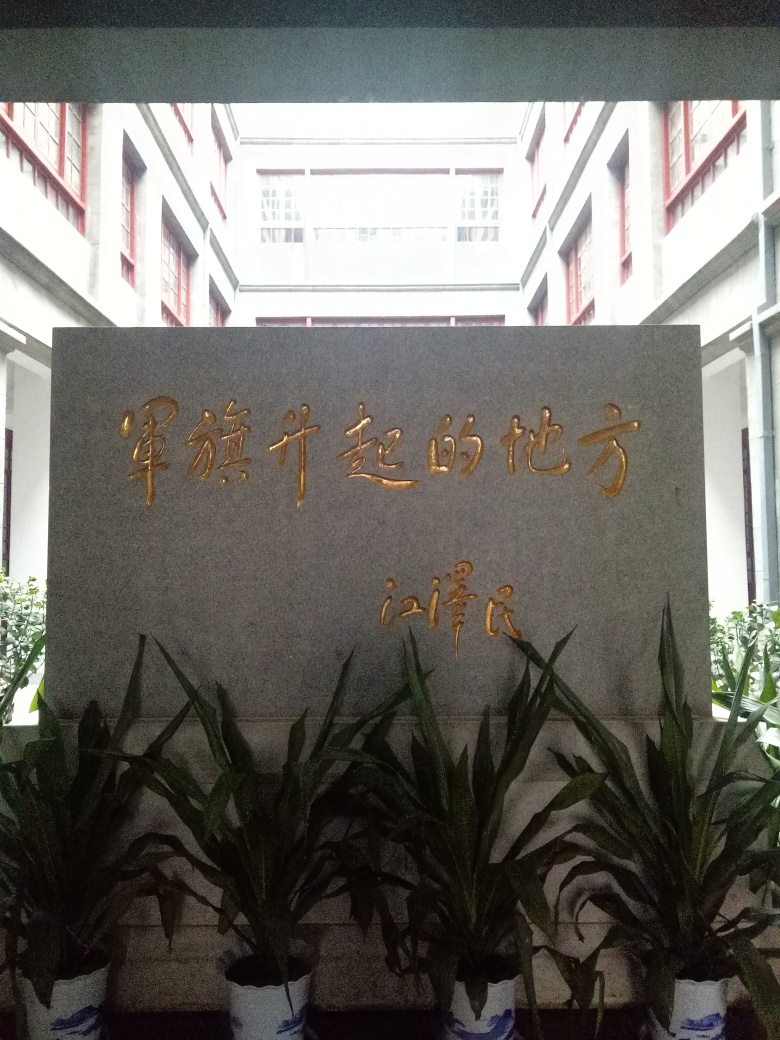Is the composition of the image not satisfactory? While 'No' is indeed an answer, it could be expanded upon for clarification. The composition may benefit from improved lighting to accentuate the features of the monument and reduce shadowing. Additionally, angling the shot to include a bit more of the surrounding context could help to situate the monument within its environment and enhance its presence. 